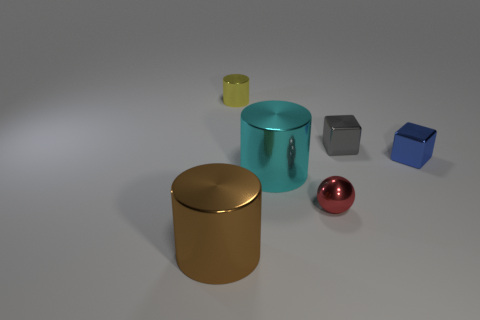Do the ball and the small cylinder have the same color?
Provide a succinct answer. No. How many other objects are the same material as the big brown thing?
Provide a short and direct response. 5. There is a shiny sphere; what number of tiny things are on the right side of it?
Give a very brief answer. 2. What size is the cyan metallic object that is the same shape as the yellow metal object?
Provide a short and direct response. Large. How many brown objects are either metal cubes or large things?
Ensure brevity in your answer.  1. There is a thing in front of the small red object; what number of brown cylinders are right of it?
Keep it short and to the point. 0. How many other things are there of the same shape as the blue metallic object?
Provide a succinct answer. 1. What number of tiny objects are the same color as the tiny metal ball?
Give a very brief answer. 0. The small sphere that is the same material as the tiny gray thing is what color?
Make the answer very short. Red. Are there any blocks that have the same size as the cyan metal thing?
Ensure brevity in your answer.  No. 